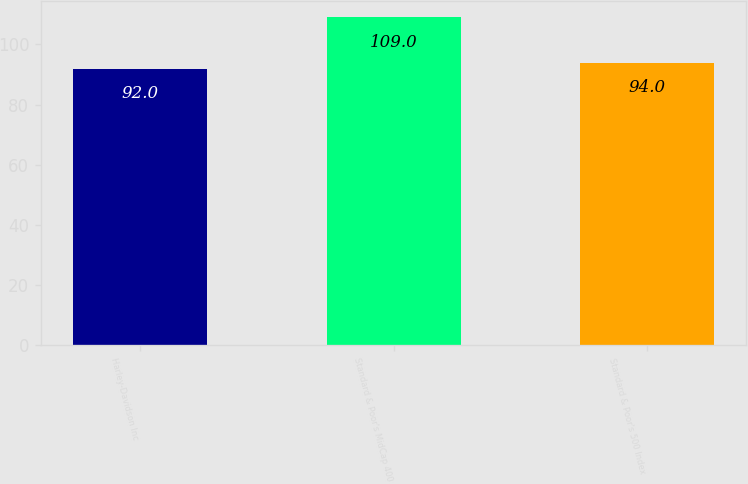Convert chart. <chart><loc_0><loc_0><loc_500><loc_500><bar_chart><fcel>Harley-Davidson Inc<fcel>Standard & Poor's MidCap 400<fcel>Standard & Poor's 500 Index<nl><fcel>92<fcel>109<fcel>94<nl></chart> 